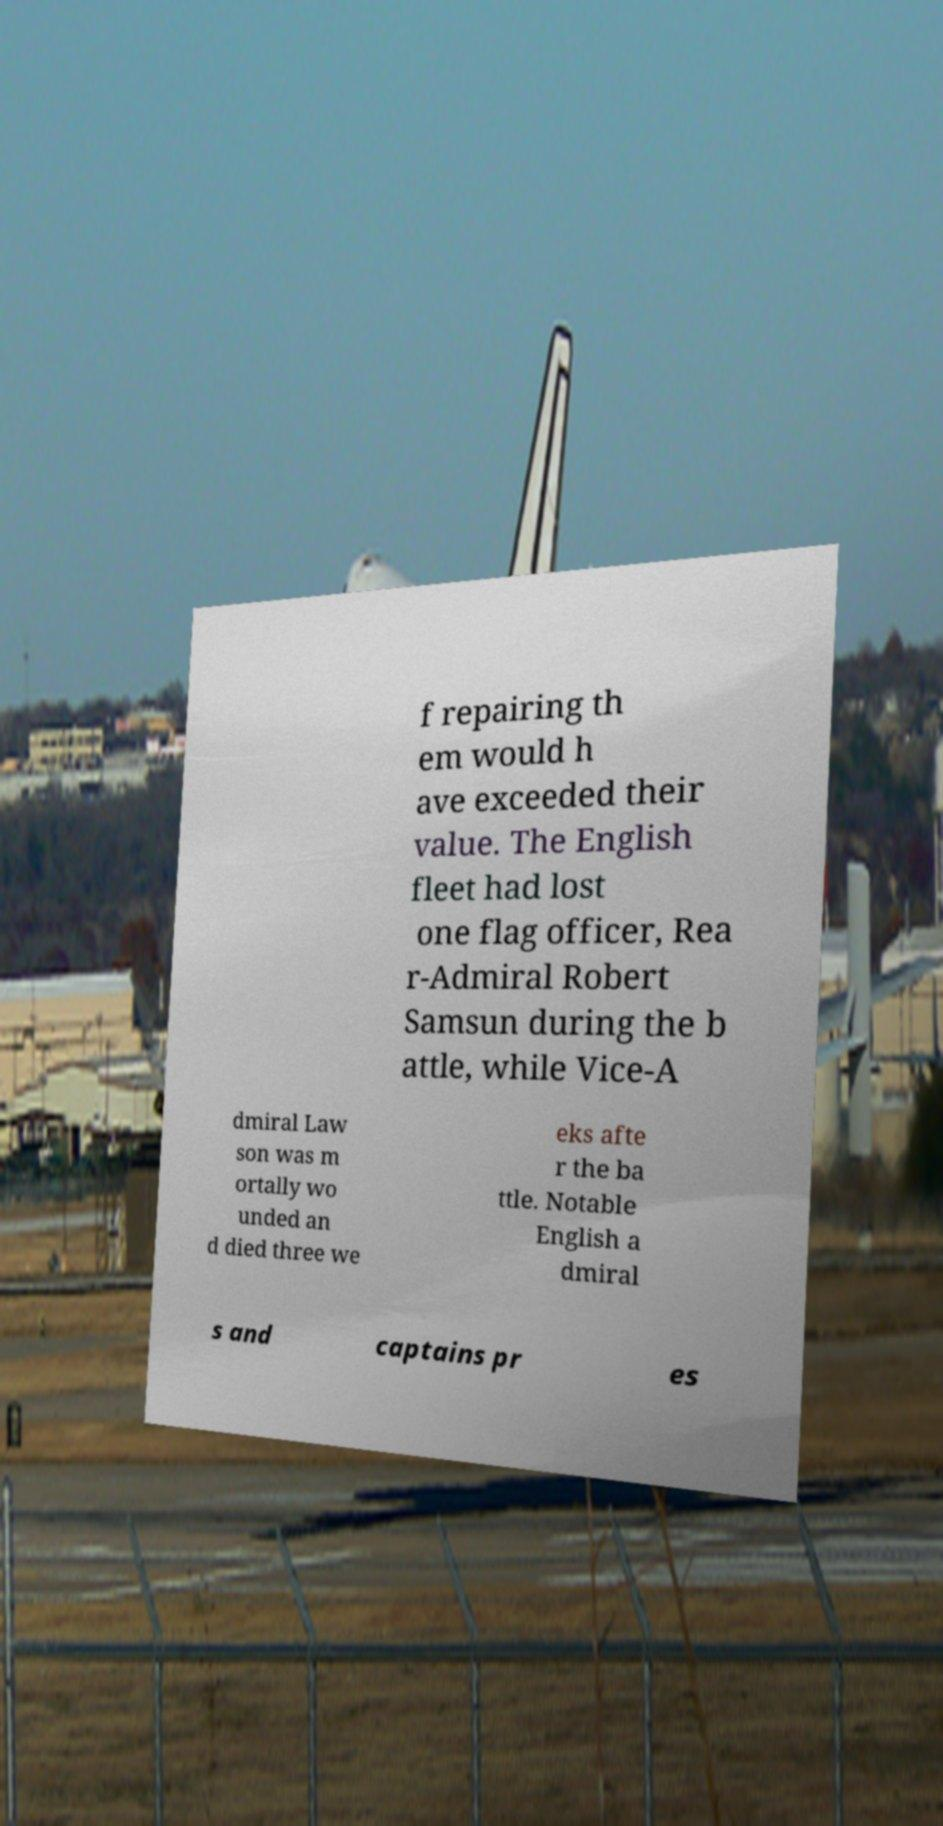Please identify and transcribe the text found in this image. f repairing th em would h ave exceeded their value. The English fleet had lost one flag officer, Rea r-Admiral Robert Samsun during the b attle, while Vice-A dmiral Law son was m ortally wo unded an d died three we eks afte r the ba ttle. Notable English a dmiral s and captains pr es 